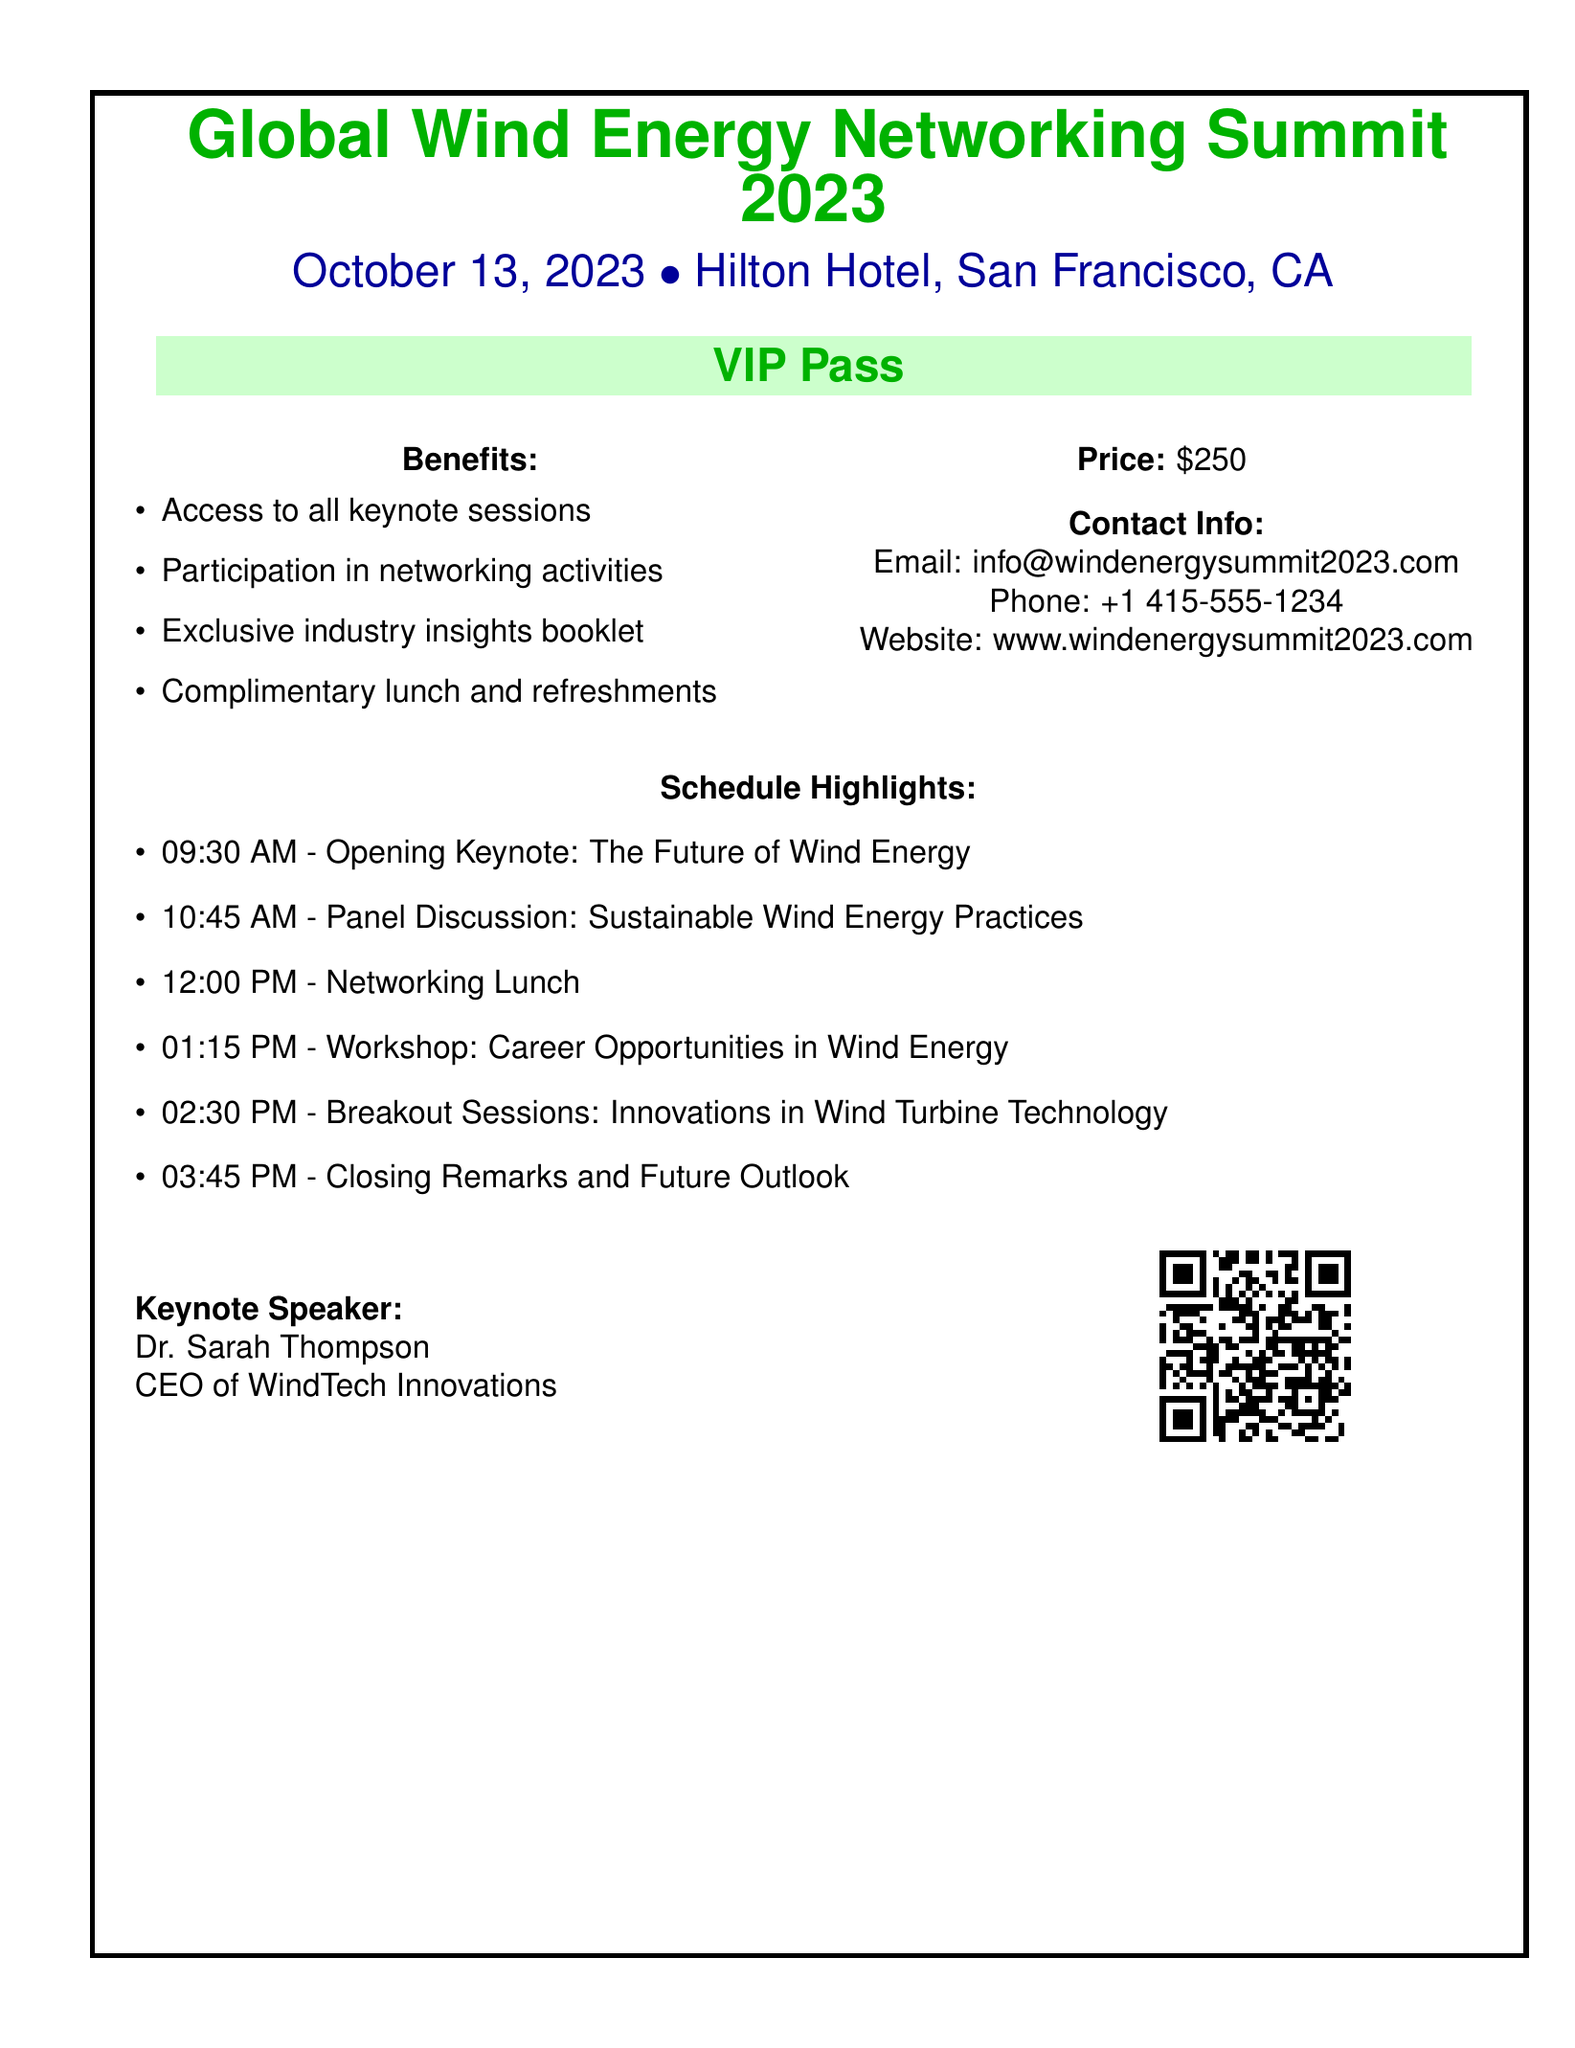What is the name of the event? The name of the event is stated prominently at the top of the document.
Answer: Global Wind Energy Networking Summit 2023 When is the event scheduled? The event date is provided in the document near the event name.
Answer: October 13, 2023 Where will the event take place? The venue of the event is mentioned in the document.
Answer: Hilton Hotel, San Francisco, CA What is the price of the VIP pass? The price information is included in the document.
Answer: $250 Who is the keynote speaker? The document specifies the name of the keynote speaker and her title.
Answer: Dr. Sarah Thompson What is one benefit of the VIP pass? The document lists several benefits of the VIP pass.
Answer: Access to all keynote sessions What time does the networking lunch start? The schedule includes the time for the networking lunch.
Answer: 12:00 PM How many sessions are listed in the schedule highlights? By counting the items in the schedule, we can find the total number of sessions.
Answer: 6 What is the title of the opening keynote? The title of the opening keynote is included in the schedule highlights.
Answer: The Future of Wind Energy 